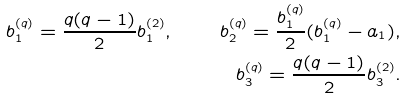<formula> <loc_0><loc_0><loc_500><loc_500>b _ { 1 } ^ { ( q ) } = \frac { q ( q - 1 ) } { 2 } b _ { 1 } ^ { ( 2 ) } , \quad b _ { 2 } ^ { ( q ) } = \frac { b _ { 1 } ^ { ( q ) } } { 2 } ( b _ { 1 } ^ { ( q ) } - a _ { 1 } ) , \\ b _ { 3 } ^ { ( q ) } = \frac { q ( q - 1 ) } { 2 } b _ { 3 } ^ { ( 2 ) } .</formula> 